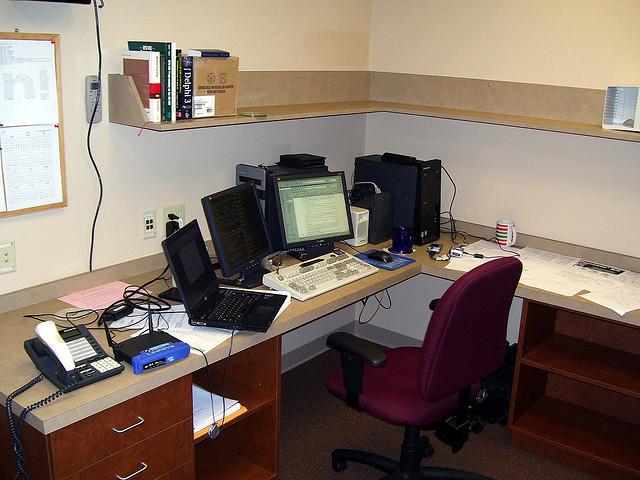What color is the computer monitor?
Quick response, please. Black. Are the papers organized?
Give a very brief answer. Yes. How many books are in the room?
Quick response, please. 6. What is sitting on the far left of the desk?
Answer briefly. Telephone. 